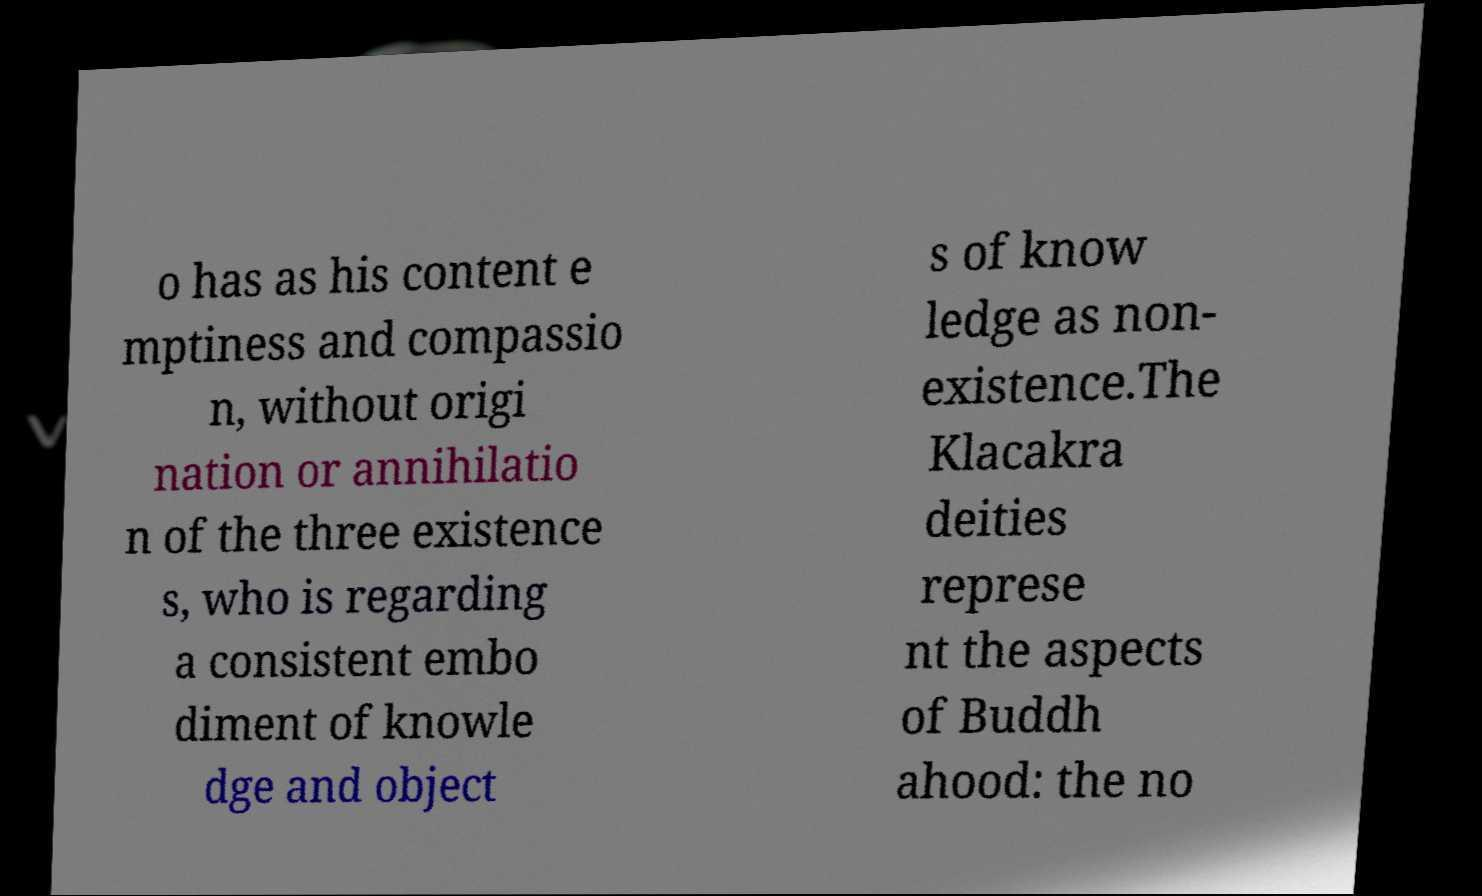Could you assist in decoding the text presented in this image and type it out clearly? o has as his content e mptiness and compassio n, without origi nation or annihilatio n of the three existence s, who is regarding a consistent embo diment of knowle dge and object s of know ledge as non- existence.The Klacakra deities represe nt the aspects of Buddh ahood: the no 